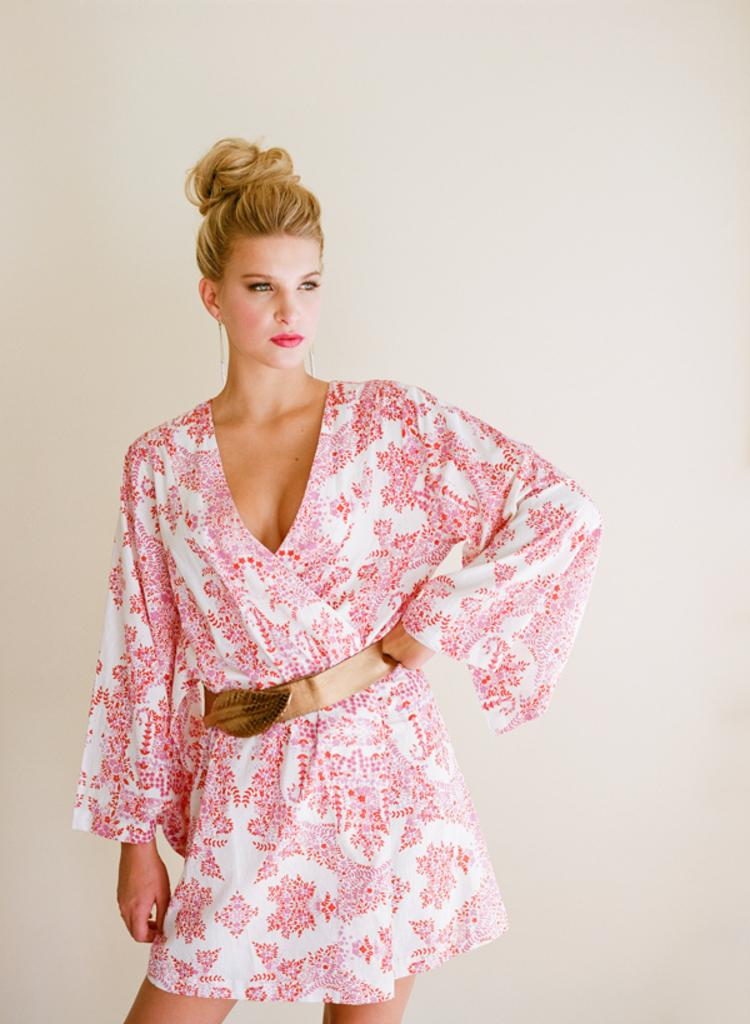Who is the main subject in the image? There is a woman in the image. What is the woman doing in the image? The woman is standing in front of a wall. What is the woman wearing in the image? The woman is wearing a red dress and a belt. Can you see a kitten playing with dirt in the image? There is no kitten or dirt present in the image. What is the woman laughing at in the image? The image does not show the woman laughing or any specific object that she might be laughing at. 